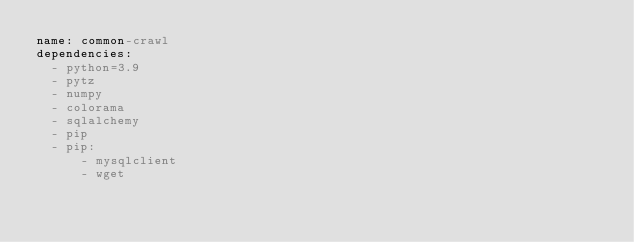Convert code to text. <code><loc_0><loc_0><loc_500><loc_500><_YAML_>name: common-crawl
dependencies:
  - python=3.9
  - pytz
  - numpy
  - colorama
  - sqlalchemy
  - pip
  - pip:
      - mysqlclient
      - wget
</code> 